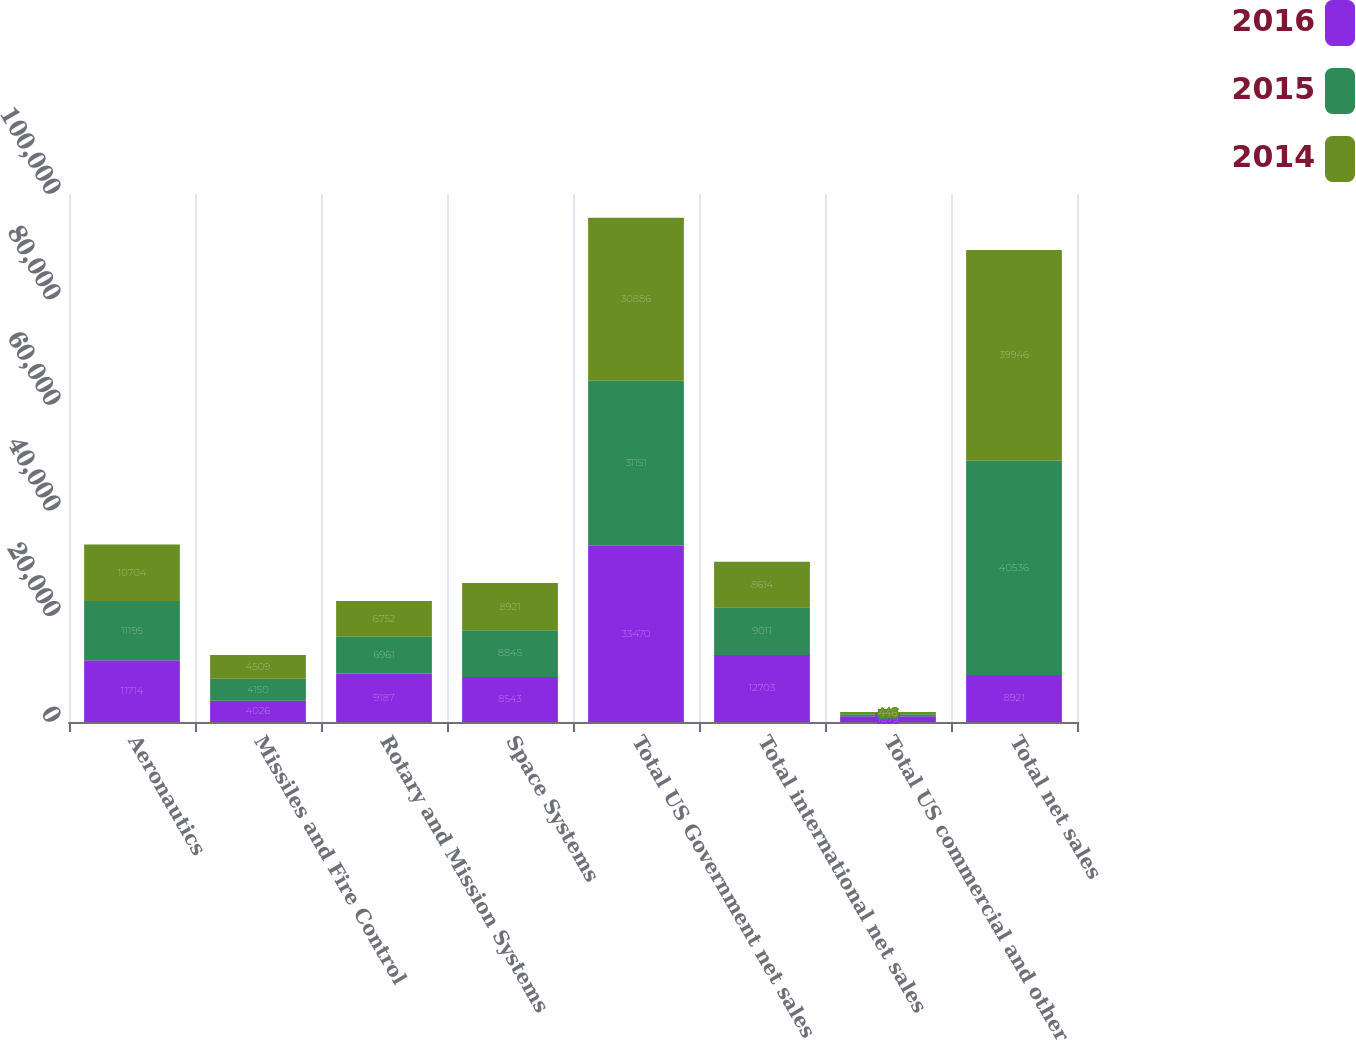Convert chart. <chart><loc_0><loc_0><loc_500><loc_500><stacked_bar_chart><ecel><fcel>Aeronautics<fcel>Missiles and Fire Control<fcel>Rotary and Mission Systems<fcel>Space Systems<fcel>Total US Government net sales<fcel>Total international net sales<fcel>Total US commercial and other<fcel>Total net sales<nl><fcel>2016<fcel>11714<fcel>4026<fcel>9187<fcel>8543<fcel>33470<fcel>12703<fcel>1075<fcel>8921<nl><fcel>2015<fcel>11195<fcel>4150<fcel>6961<fcel>8845<fcel>31151<fcel>9011<fcel>374<fcel>40536<nl><fcel>2014<fcel>10704<fcel>4509<fcel>6752<fcel>8921<fcel>30886<fcel>8614<fcel>446<fcel>39946<nl></chart> 